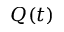Convert formula to latex. <formula><loc_0><loc_0><loc_500><loc_500>Q ( t )</formula> 